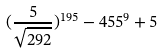Convert formula to latex. <formula><loc_0><loc_0><loc_500><loc_500>( \frac { 5 } { \sqrt { 2 9 2 } } ) ^ { 1 9 5 } - 4 5 5 ^ { 9 } + 5</formula> 